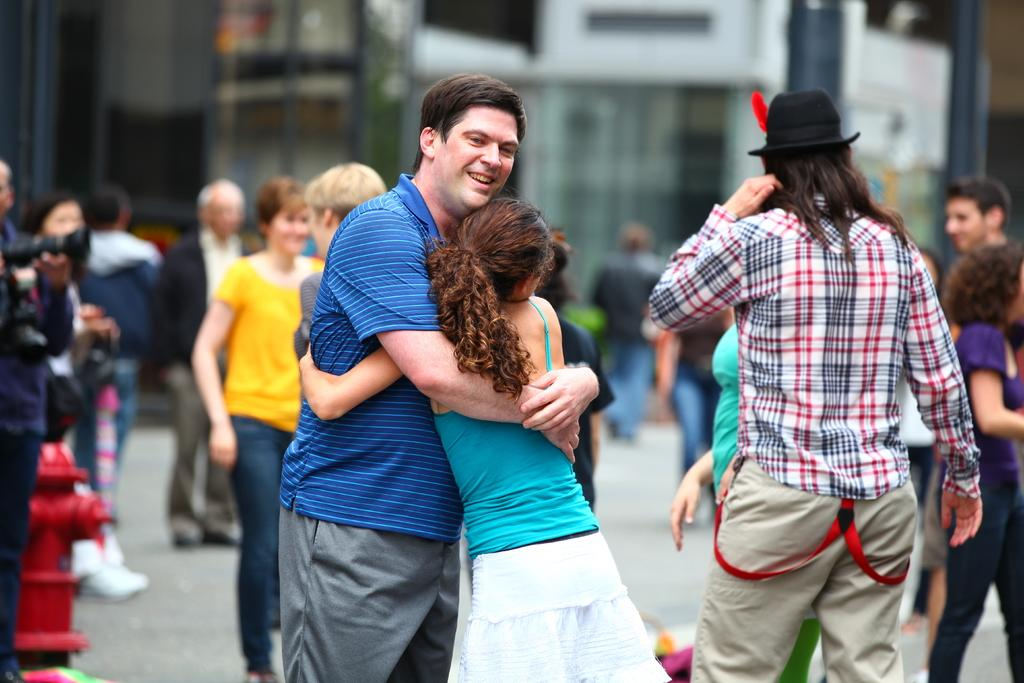How many people are in the image? There is a group of people in the image. What are the people wearing? The people are wearing clothes. Can you describe the interaction between two of the people? Two persons are hugging in the middle of the image. What object can be seen in the bottom left of the image? There is a fire hose in the bottom left of the image. Where is the grandmother holding the duck in the image? There is no grandmother or duck present in the image. 